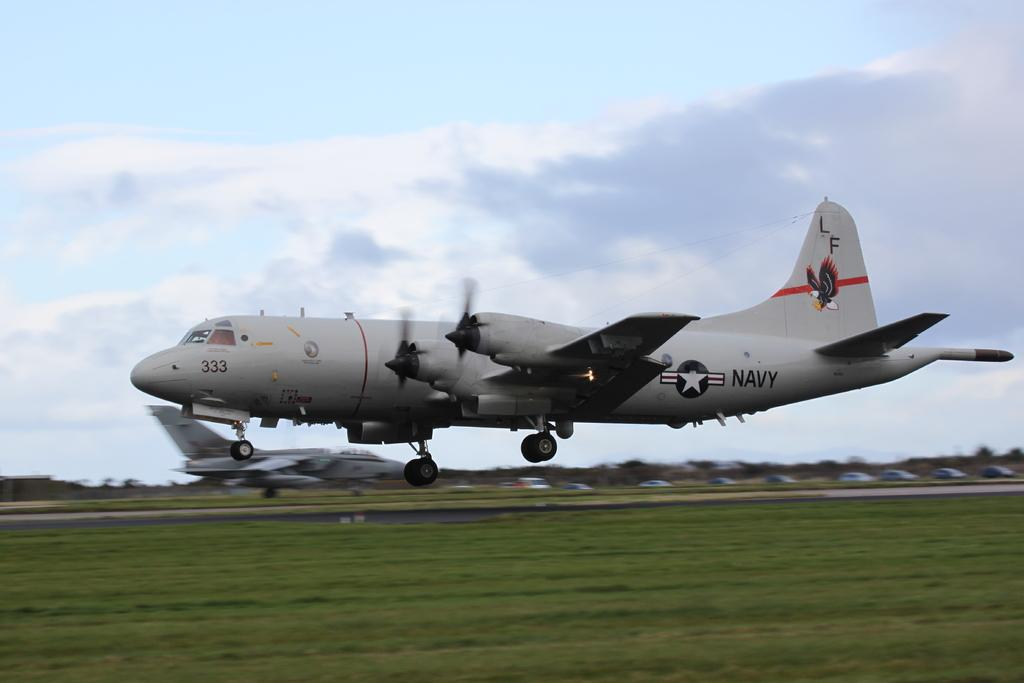<image>
Write a terse but informative summary of the picture. A US Navy plane has an eagle and the letters LF on the tail. 